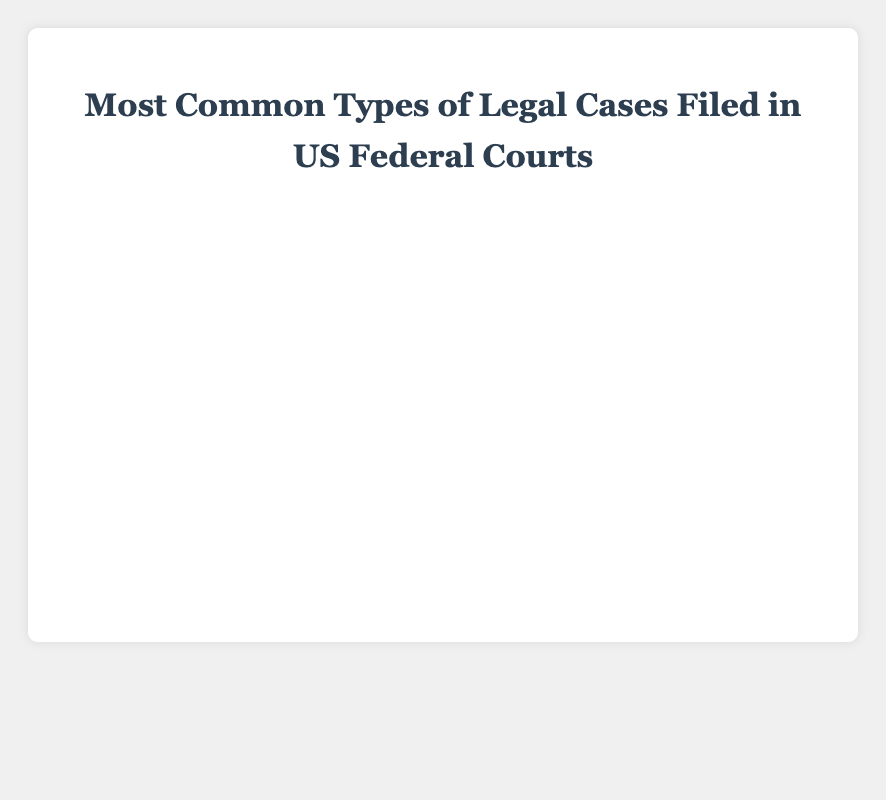What is the most common type of legal case filed in US federal courts? The bar chart shows that the "Criminal" category has the highest percentage of cases at 25%.
Answer: Criminal Which type of legal case has the least percentage of cases filed in US federal courts? The bar chart shows that the "Antitrust" category has the smallest percentage of cases at 2%.
Answer: Antitrust How much greater is the percentage of Criminal cases compared to Labor cases? The percentage of Criminal cases is 25%, while Labor cases are 15%. The difference is 25% - 15% = 10%.
Answer: 10% What is the combined percentage of Civil Rights, Labor, and Securities cases? The percentages are Civil Rights (20%), Labor (15%), and Securities (10%). The total is 20% + 15% + 10% = 45%.
Answer: 45% Which category has a higher percentage, Environmental or Contract cases? The bar chart shows Environmental cases at 8% and Contract cases at 12%. Contract cases have a higher percentage.
Answer: Contract What is the difference in percentage between Bankruptcy and Intellectual Property cases? Bankruptcy cases have a percentage of 5%, while Intellectual Property cases have 3%. The difference is 5% - 3% = 2%.
Answer: 2% What is the average percentage of cases for Contract, Securities, and Environmental categories? Sum the percentages: Contract (12%), Securities (10%), and Environmental (8%), which is 12% + 10% + 8% = 30%. The average is 30% / 3 = 10%.
Answer: 10% Are there more than twice as many Criminal cases as there are Bankruptcy cases? The percentage of Criminal cases is 25%, and Bankruptcy cases are 5%. Twice the Bankruptcy cases would be 5% * 2 = 10%. Since 25% is more than 10%, there are more than twice as many Criminal cases.
Answer: Yes Is the percentage of Labor cases closer to Civil Rights or Contract cases? The percentage of Labor cases is 15%, Civil Rights is 20%, and Contract is 12%. The difference from Labor to Civil Rights is 20% - 15% = 5%, and to Contract is 15% - 12% = 3%. It is closer to Contract.
Answer: Contract What is the relative ranking of Securities cases in comparison to the other categories? The categories sorted by percentage in descending order are: Criminal, Civil Rights, Labor, Contract, Securities, Environmental, Bankruptcy, Intellectual Property, Antitrust. Securities is ranked 5th.
Answer: 5th 